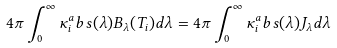Convert formula to latex. <formula><loc_0><loc_0><loc_500><loc_500>4 \pi \int _ { 0 } ^ { \infty } \kappa _ { i } ^ { a } b s ( \lambda ) B _ { \lambda } ( T _ { i } ) d \lambda = 4 \pi \int _ { 0 } ^ { \infty } \kappa _ { i } ^ { a } b s ( \lambda ) J _ { \lambda } d \lambda</formula> 